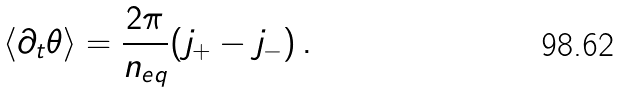Convert formula to latex. <formula><loc_0><loc_0><loc_500><loc_500>\langle \partial _ { t } \theta \rangle = \frac { 2 \pi } { n _ { e q } } ( j _ { + } - j _ { - } ) \, .</formula> 